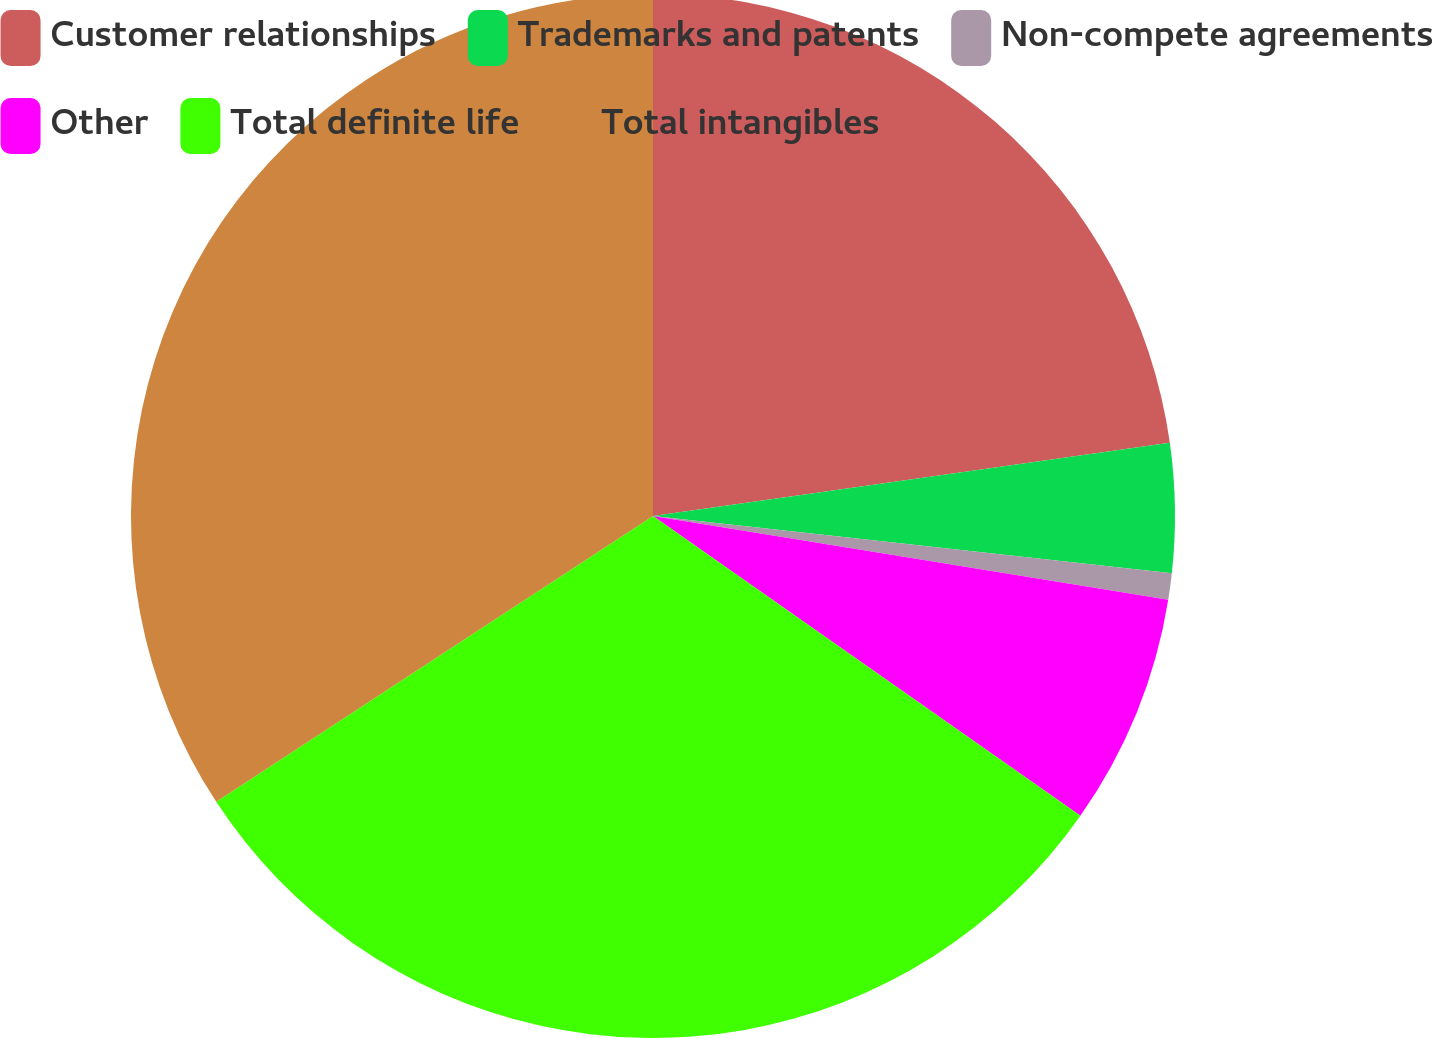Convert chart. <chart><loc_0><loc_0><loc_500><loc_500><pie_chart><fcel>Customer relationships<fcel>Trademarks and patents<fcel>Non-compete agreements<fcel>Other<fcel>Total definite life<fcel>Total intangibles<nl><fcel>22.76%<fcel>3.99%<fcel>0.81%<fcel>7.17%<fcel>31.04%<fcel>34.22%<nl></chart> 